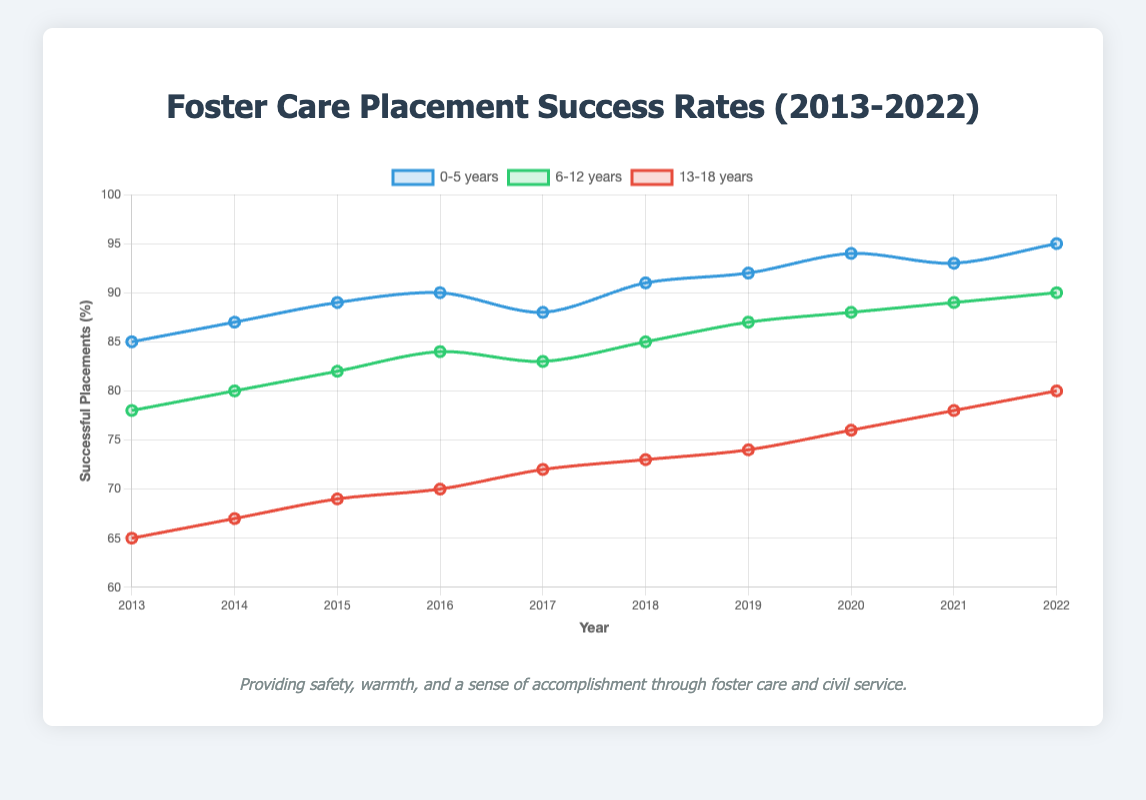What is the highest success rate for foster care placements for the age group 13-18 years and in which year? First, look at the "13-18 years" data on the graph. The highest value is 80%, which occurs in 2022.
Answer: 80% in 2022 Which age group had the highest success rate in 2019? In the year 2019, compare the success rates of all age groups. The "0-5 years" group had a success rate of 92%, which is the highest among all age groups.
Answer: 0-5 years How does the success rate for the age group 6-12 years in 2017 compare to that in 2022? Look at the data for the "6-12 years" group in 2017, which is 83%, and in 2022, which is 90%. 2022's rate is higher than 2017's rate.
Answer: Higher in 2022 Which age group showed the most improvement in their success rates from 2013 to 2022? Calculate the difference between the success rates in 2022 and 2013 for each age group. The improvements are: 
0-5 years: 95 - 85 = 10%
6-12 years: 90 - 78 = 12%
13-18 years: 80 - 65 = 15%
The "13-18 years" group has the highest improvement of 15%.
Answer: 13-18 years What is the average success rate for the age group 0-5 years over the decade shown? Sum the success rates from 2013 to 2022 for the "0-5 years" group and divide by the number of years. 
(85 + 87 + 89 + 90 + 88 + 91 + 92 + 94 + 93 + 95) / 10 = 90.4
Answer: 90.4% Compare the trend in success rates for the age groups 0-5 years and 6-12 years from 2016 to 2020. Observe the line trends for these age groups during 2016 to 2020.
- "0-5 years" starts at 90% in 2016 and ends at 94% in 2020.
- "6-12 years" starts at 84% in 2016 and ends at 88% in 2020.
Both age groups show an upward trend, but "0-5 years" shows a higher increase.
Answer: Both upward; 0-5 years increased more In which years did the age group 13-18 years show a consistent year-over-year increase? Analyze the data points for "13-18 years" to see which years have a consistent increase compared to the previous year. The consecutive year-over-year increases occur from 2016 (70%) to 2017 (72%), from 2017 (72%) to 2018 (73%), from 2018 (73%) to 2019 (74%), and so on up to 2022.
Answer: 2016 to 2022 What visual elements indicate the highest success rate for each age group within the graph? Look at the points along the curves for each age group that reach the highest value on the Y-axis.
- "0-5 years": Highest rate is at 95%, visualized by the topmost point on the blue line.
- "6-12 years": Highest rate is at 90%, visualized by the topmost point on the green line.
- "13-18 years": Highest rate is at 80%, visualized by the topmost point on the red line.
Answer: Points on lines at 95% (blue), 90% (green), 80% (red) Was there a year when all age groups reached a success rate of 90% or above? Compare the success rates of all age groups across different years. The year 2022 shows that all age groups are at or above 90%.
"0-5 years": 95%
"6-12 years": 90%
"13-18 years": 80% does not reach 90%, thus no such year exists.
Answer: No 